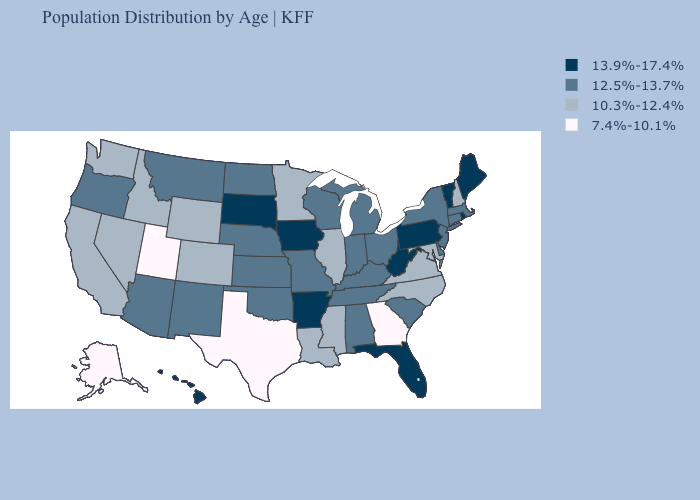What is the value of Alaska?
Be succinct. 7.4%-10.1%. Does New York have a higher value than Virginia?
Concise answer only. Yes. Name the states that have a value in the range 10.3%-12.4%?
Quick response, please. California, Colorado, Idaho, Illinois, Louisiana, Maryland, Minnesota, Mississippi, Nevada, New Hampshire, North Carolina, Virginia, Washington, Wyoming. Does Rhode Island have the same value as Arkansas?
Keep it brief. Yes. Name the states that have a value in the range 7.4%-10.1%?
Write a very short answer. Alaska, Georgia, Texas, Utah. Which states have the lowest value in the USA?
Quick response, please. Alaska, Georgia, Texas, Utah. What is the highest value in states that border Maryland?
Concise answer only. 13.9%-17.4%. What is the value of Michigan?
Write a very short answer. 12.5%-13.7%. What is the highest value in states that border Massachusetts?
Short answer required. 13.9%-17.4%. What is the value of Michigan?
Be succinct. 12.5%-13.7%. Which states hav the highest value in the West?
Short answer required. Hawaii. Name the states that have a value in the range 13.9%-17.4%?
Quick response, please. Arkansas, Florida, Hawaii, Iowa, Maine, Pennsylvania, Rhode Island, South Dakota, Vermont, West Virginia. Does Florida have the highest value in the South?
Keep it brief. Yes. Name the states that have a value in the range 12.5%-13.7%?
Write a very short answer. Alabama, Arizona, Connecticut, Delaware, Indiana, Kansas, Kentucky, Massachusetts, Michigan, Missouri, Montana, Nebraska, New Jersey, New Mexico, New York, North Dakota, Ohio, Oklahoma, Oregon, South Carolina, Tennessee, Wisconsin. Does Indiana have a higher value than Idaho?
Short answer required. Yes. 